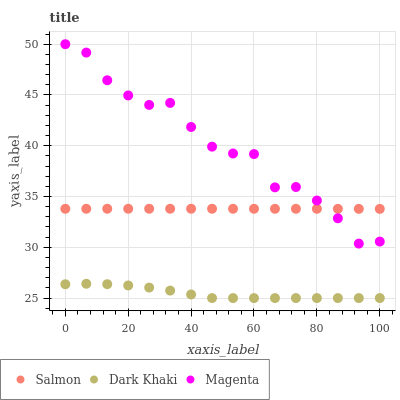Does Dark Khaki have the minimum area under the curve?
Answer yes or no. Yes. Does Magenta have the maximum area under the curve?
Answer yes or no. Yes. Does Salmon have the minimum area under the curve?
Answer yes or no. No. Does Salmon have the maximum area under the curve?
Answer yes or no. No. Is Salmon the smoothest?
Answer yes or no. Yes. Is Magenta the roughest?
Answer yes or no. Yes. Is Magenta the smoothest?
Answer yes or no. No. Is Salmon the roughest?
Answer yes or no. No. Does Dark Khaki have the lowest value?
Answer yes or no. Yes. Does Magenta have the lowest value?
Answer yes or no. No. Does Magenta have the highest value?
Answer yes or no. Yes. Does Salmon have the highest value?
Answer yes or no. No. Is Dark Khaki less than Salmon?
Answer yes or no. Yes. Is Magenta greater than Dark Khaki?
Answer yes or no. Yes. Does Magenta intersect Salmon?
Answer yes or no. Yes. Is Magenta less than Salmon?
Answer yes or no. No. Is Magenta greater than Salmon?
Answer yes or no. No. Does Dark Khaki intersect Salmon?
Answer yes or no. No. 